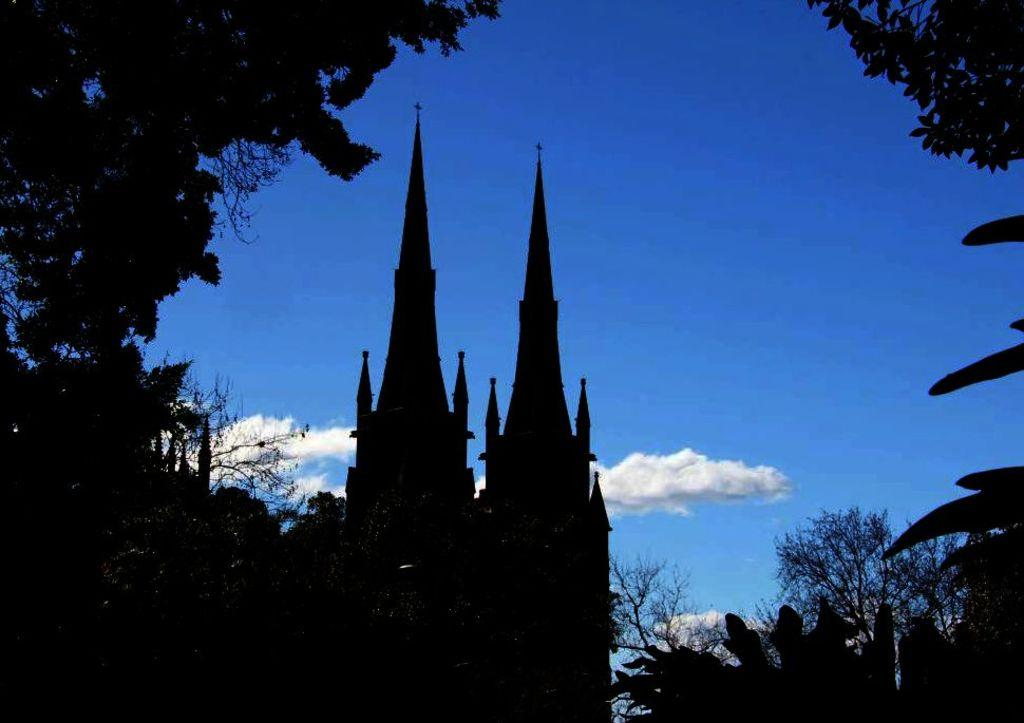What is the main structure in the center of the image? There is a tower in the center of the image. What type of vegetation can be seen in the image? There are trees in the image. What can be seen in the background of the image? The sky is visible in the background of the image. How does the tower attack the trees in the image? The tower does not attack the trees in the image; it is a stationary structure. 